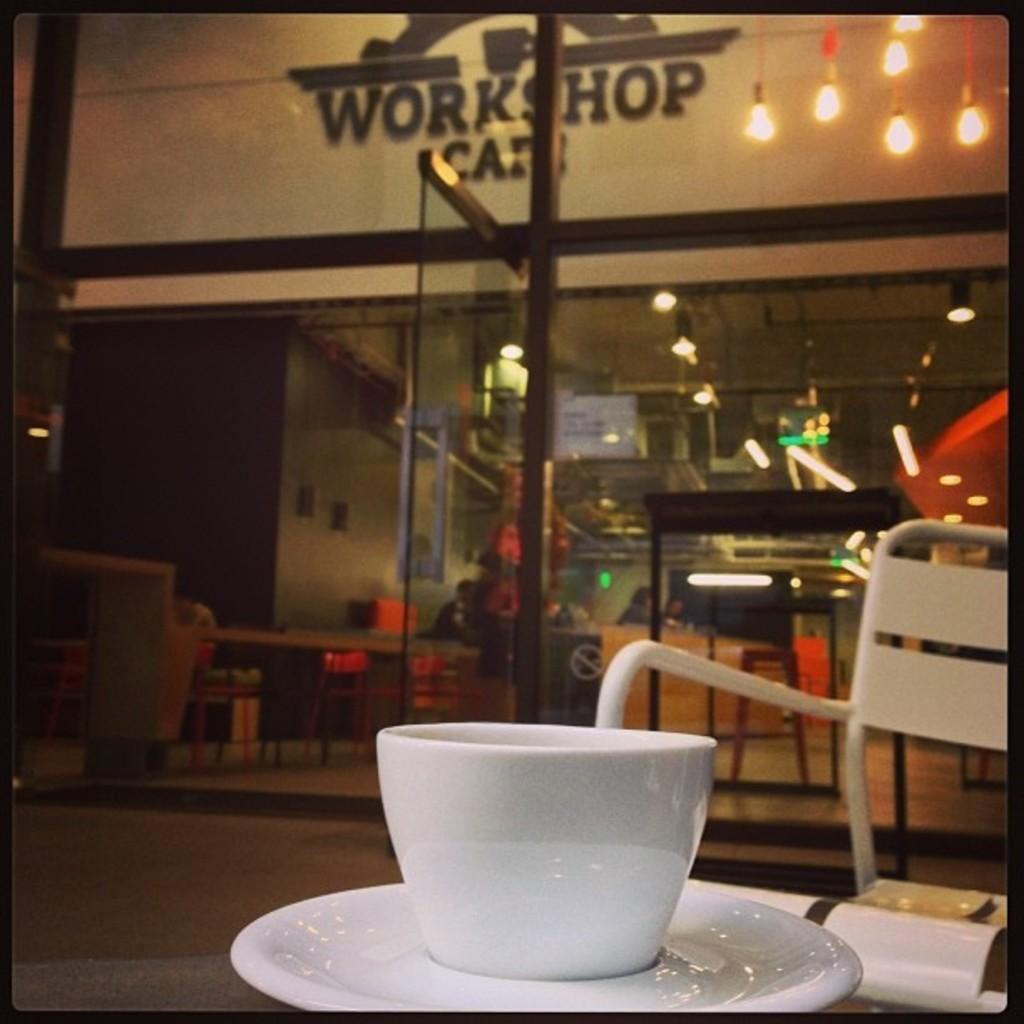<image>
Create a compact narrative representing the image presented. A cup and saucer are on a table in front of Workshop Cafe. 